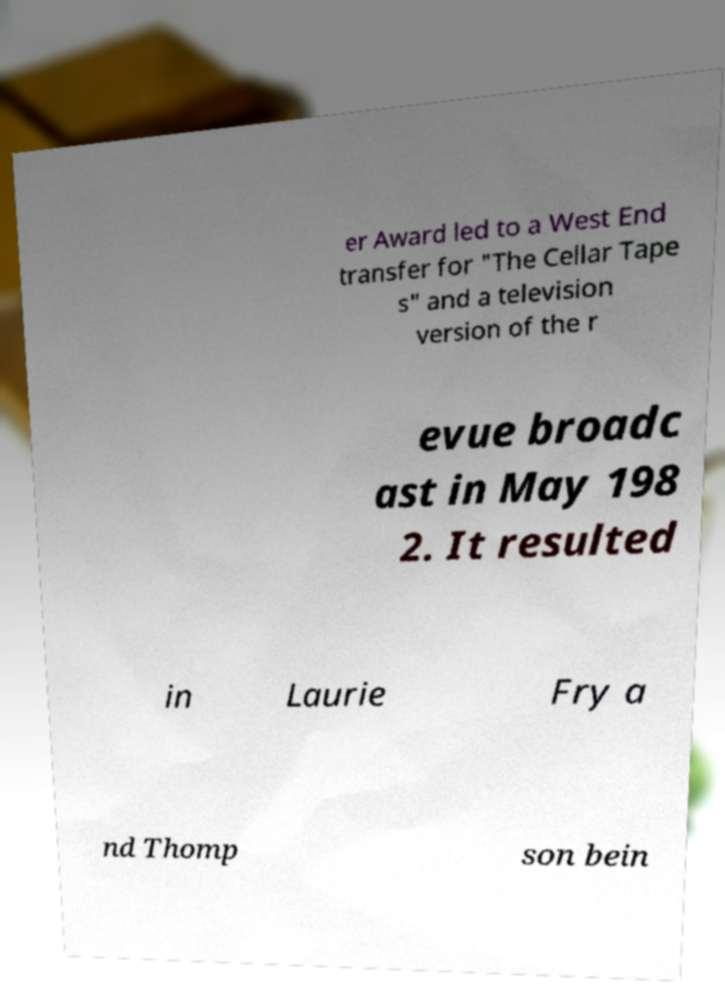What messages or text are displayed in this image? I need them in a readable, typed format. er Award led to a West End transfer for "The Cellar Tape s" and a television version of the r evue broadc ast in May 198 2. It resulted in Laurie Fry a nd Thomp son bein 